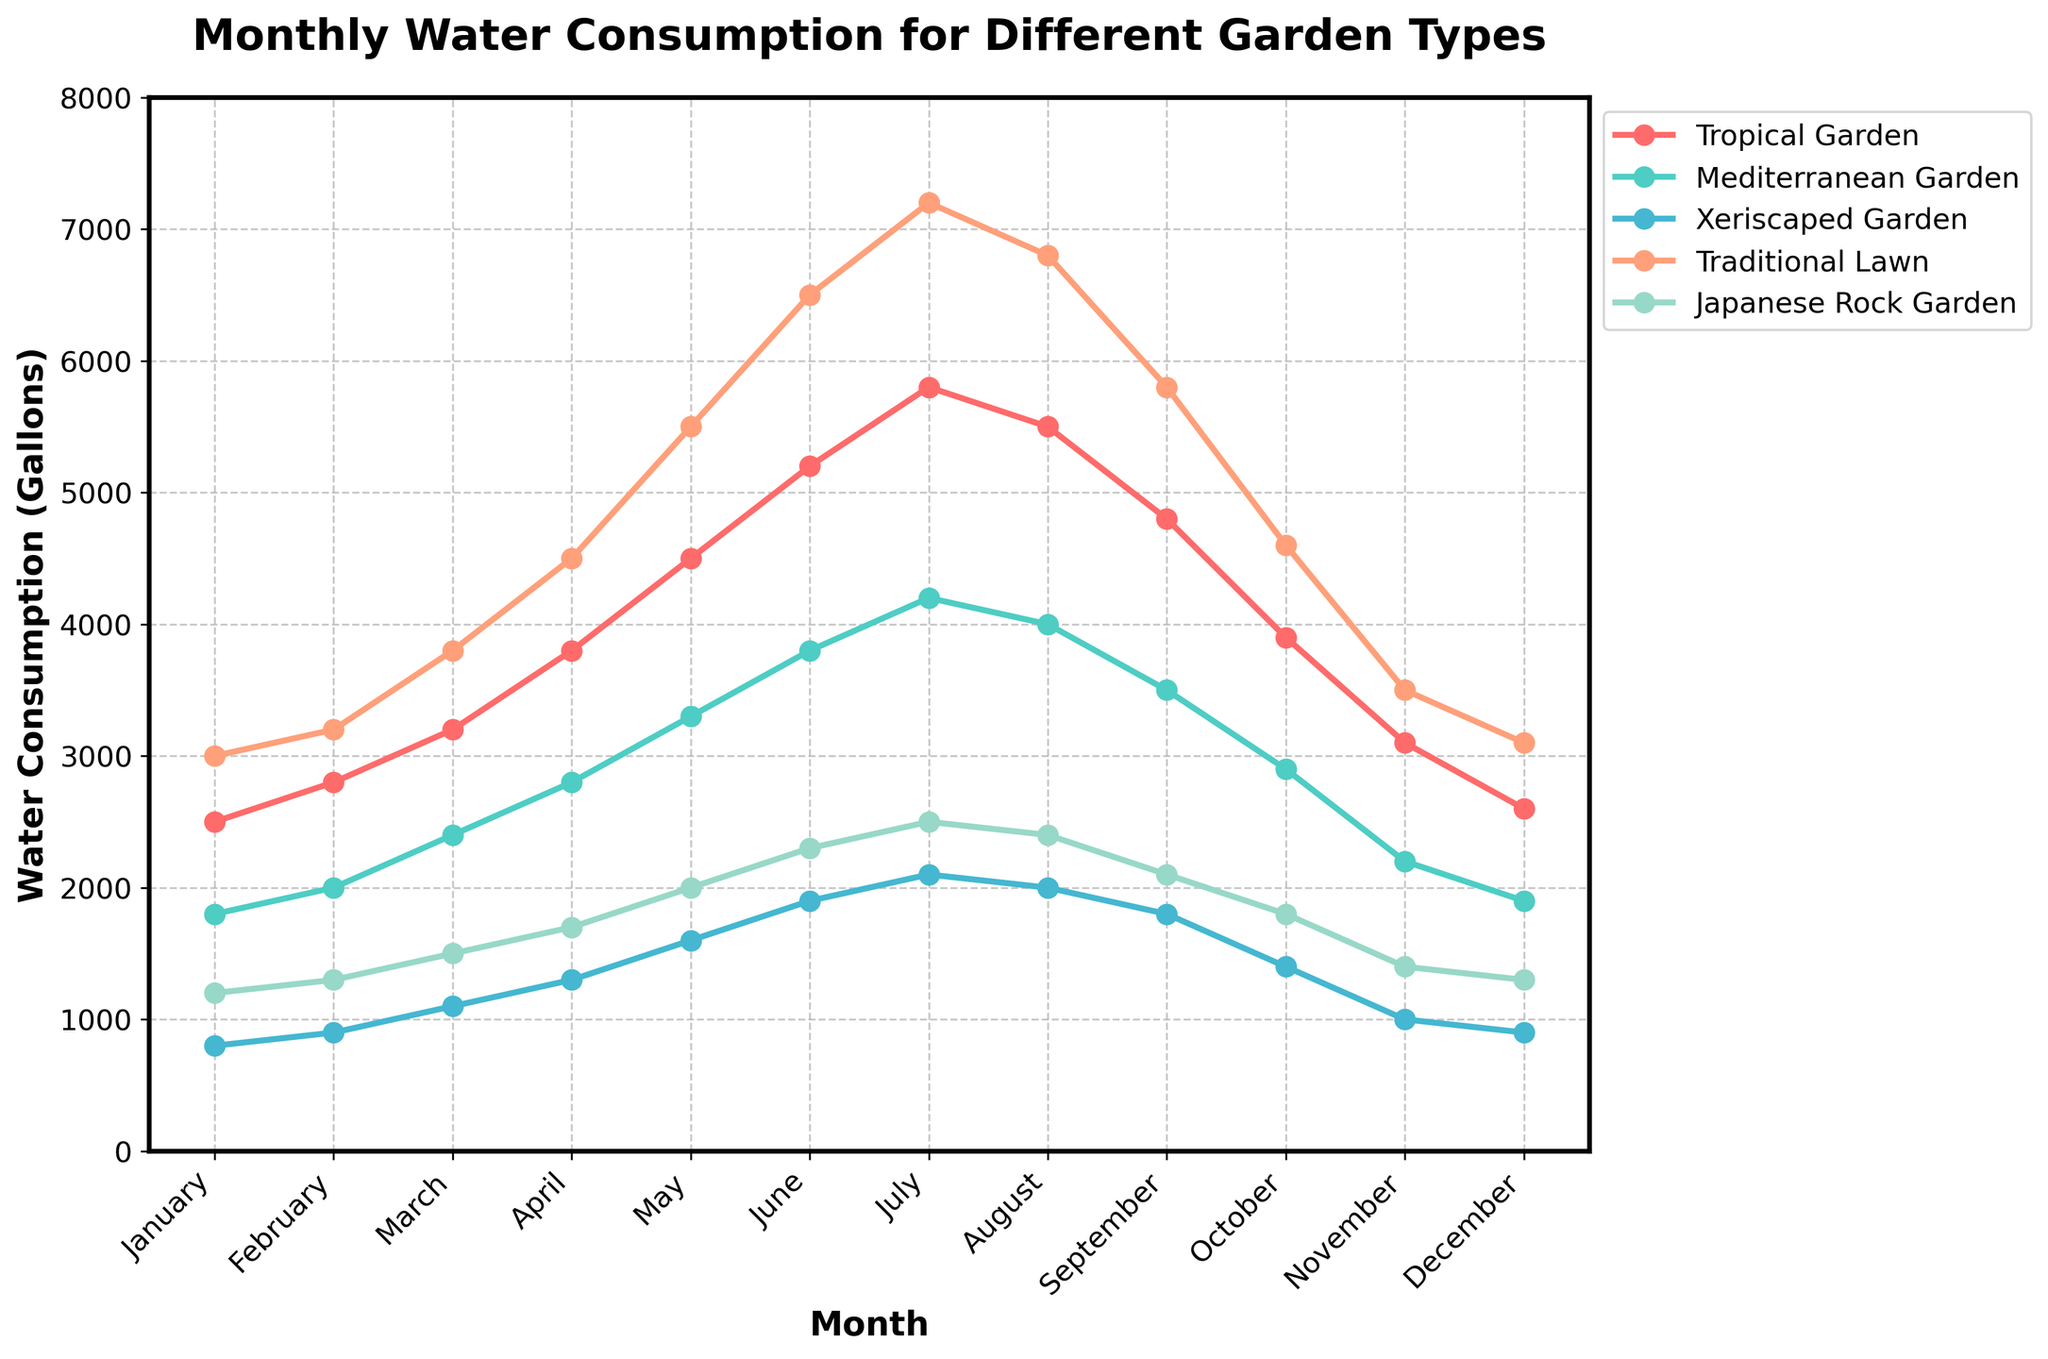What's the monthly water consumption for the Tropical Garden in July? To find the water consumption, look at the Tropical Garden line at the July point. The marker indicates that it reaches 5800 gallons.
Answer: 5800 gallons Which garden type consumed the least amount of water in March? Compare the data points for March across all garden types. The Xeriscaped Garden has the lowest marker at 1100 gallons.
Answer: Xeriscaped Garden What is the difference in water consumption between the Traditional Lawn and Mediterranean Garden in May? Find the May data points for both gardens. The Traditional Lawn is at 5500 gallons and the Mediterranean Garden is at 3300 gallons. The difference is 5500 - 3300 = 2200 gallons.
Answer: 2200 gallons What is the overall trend of water consumption for the Xeriscaped Garden throughout the year? Observe the curve for the Xeriscaped Garden throughout the year. It starts at 800 gallons in January, rises to a peak of 2100 gallons in July, and then decreases again to 900 gallons by December. The overall trend is an increase towards mid-year followed by a decrease.
Answer: Increasing then decreasing In which month did the Japanese Rock Garden have the highest water consumption? Look at the Japanese Rock Garden's data points across all months. The highest value of 2500 gallons occurs in July.
Answer: July How does the average water consumption of the Mediterranean Garden compare to that of the Tropical Garden across the year? Calculate the yearly sum for both gardens and then find the average: 
- Tropical Garden: (2500+2800+3200+3800+4500+5200+5800+5500+4800+3900+3100+2600) = 48700 gallons; average = 48700 / 12 = 4058.33 gallons.
- Mediterranean Garden: (1800+2000+2400+2800+3300+3800+4200+4000+3500+2900+2200+1900) = 35000 gallons; average = 35000 / 12 = 2916.67 gallons.
The Tropical Garden's average is higher.
Answer: Tropical Garden's average is higher Which garden types have an observable peak in water consumption during the summer months (June, July, August)? Look at the peaks of each garden type. Tropical Garden, Mediterranean Garden, Xeriscaped Garden, and Traditional Lawn all peak around these months.
Answer: Tropical Garden, Mediterranean Garden, Xeriscaped Garden, Traditional Lawn What is the total annual water consumption for the Traditional Lawn? Sum all the monthly values for the Traditional Lawn: 3000 + 3200 + 3800 + 4500 + 5500 + 6500 + 7200 + 6800 + 5800 + 4600 + 3500 + 3100 = 57500 gallons.
Answer: 57500 gallons Between which two consecutive months does the Mediterranean Garden show the greatest increase in water consumption? Calculate the difference in water consumption for Mediterranean Garden between each consecutive month:
February - January (2000 - 1800 = 200),
March - February (2400 - 2000 = 400),
April - March (2800 - 2400 = 400),
May - April (3300 - 2800 = 500),
June - May (3800 - 3300 = 500),
July - June (4200 - 3800 = 400),
August - July (4000 - 4200 = -200),
September - August (3500 - 4000 = -500),
October - September (2900 - 3500 = -600),
November - October (2200 - 2900 = -700),
December - November (1900 - 2200 = -300).
The greatest increase of 500 gallons occurs from May to June.
Answer: May to June 